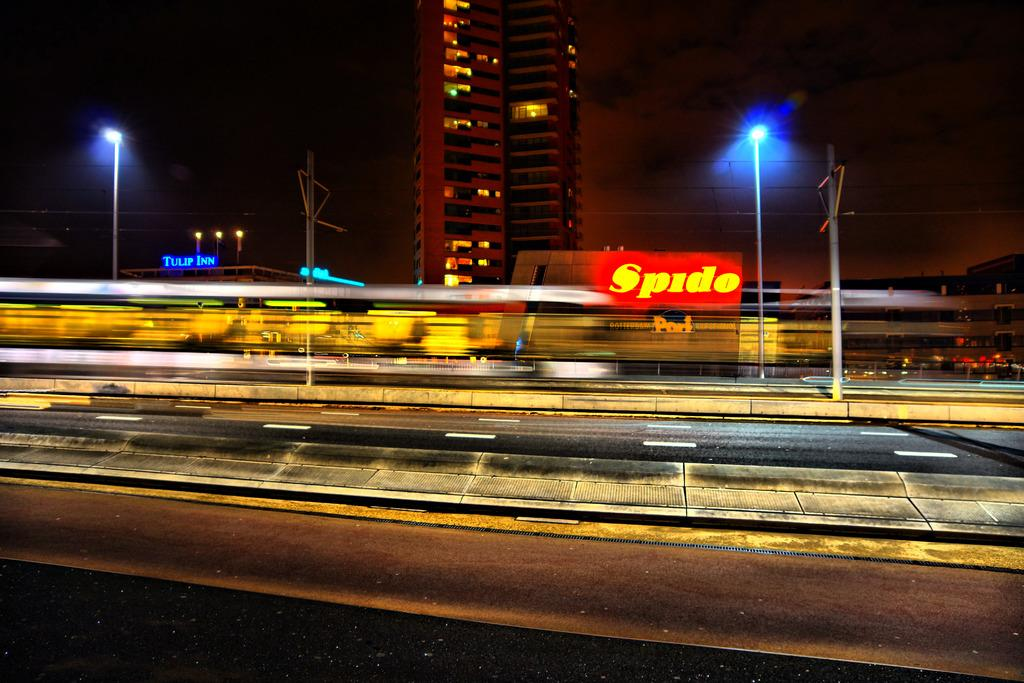What type of structures can be seen in the image? There are buildings in the image. What type of lighting is present in the image? There are street lights in the image. What else can be seen in the image besides buildings and street lights? There are wires in the image. Where is the manager standing in the image? There is no manager present in the image. What type of crack can be seen in the image? There is no crack present in the image. 